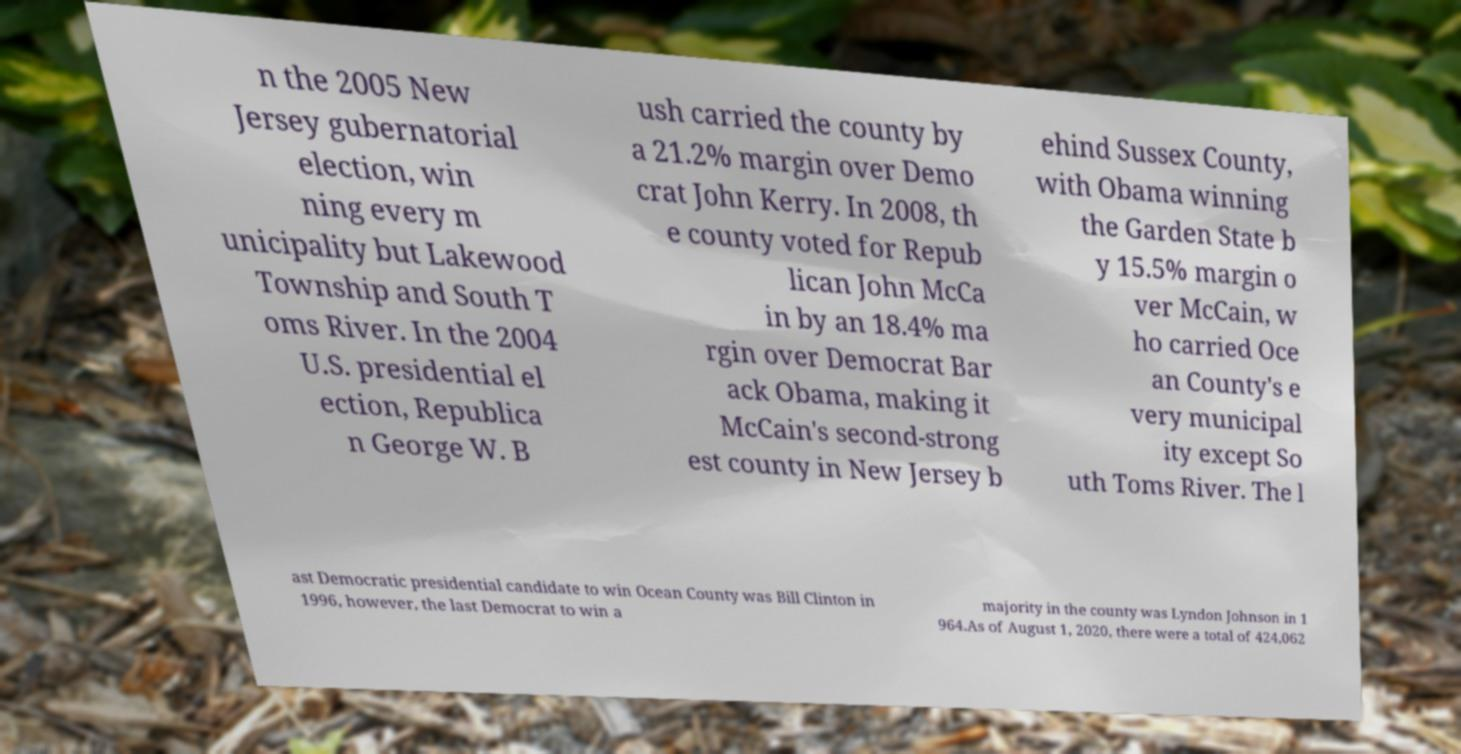Can you read and provide the text displayed in the image?This photo seems to have some interesting text. Can you extract and type it out for me? n the 2005 New Jersey gubernatorial election, win ning every m unicipality but Lakewood Township and South T oms River. In the 2004 U.S. presidential el ection, Republica n George W. B ush carried the county by a 21.2% margin over Demo crat John Kerry. In 2008, th e county voted for Repub lican John McCa in by an 18.4% ma rgin over Democrat Bar ack Obama, making it McCain's second-strong est county in New Jersey b ehind Sussex County, with Obama winning the Garden State b y 15.5% margin o ver McCain, w ho carried Oce an County's e very municipal ity except So uth Toms River. The l ast Democratic presidential candidate to win Ocean County was Bill Clinton in 1996, however, the last Democrat to win a majority in the county was Lyndon Johnson in 1 964.As of August 1, 2020, there were a total of 424,062 